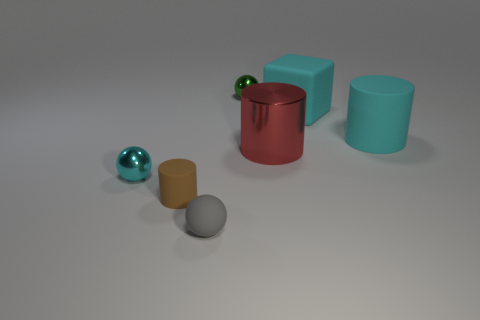How many matte cylinders are the same color as the rubber cube? After carefully examining the image, there appears to be one matte cylinder that shares the same muted teal color as the rubber cube. 